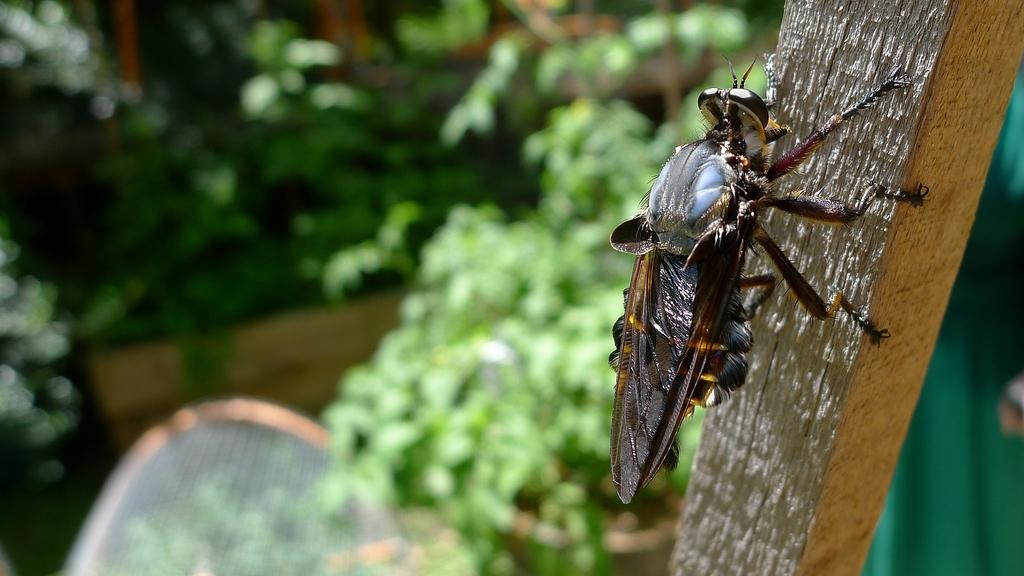What type of creature can be seen in the image? There is an insect in the image. What is the insect resting on? The insect is on a wooden stick. Can you describe the background of the image? The background of the image is blurred. What type of vegetation is visible in the image? There are plants visible in the image. What type of balance does the insect have on the wooden stick? The image does not provide information about the insect's balance on the wooden stick. Can you see a base supporting the wooden stick in the image? There is no base visible in the image; the wooden stick appears to be resting on its own. 